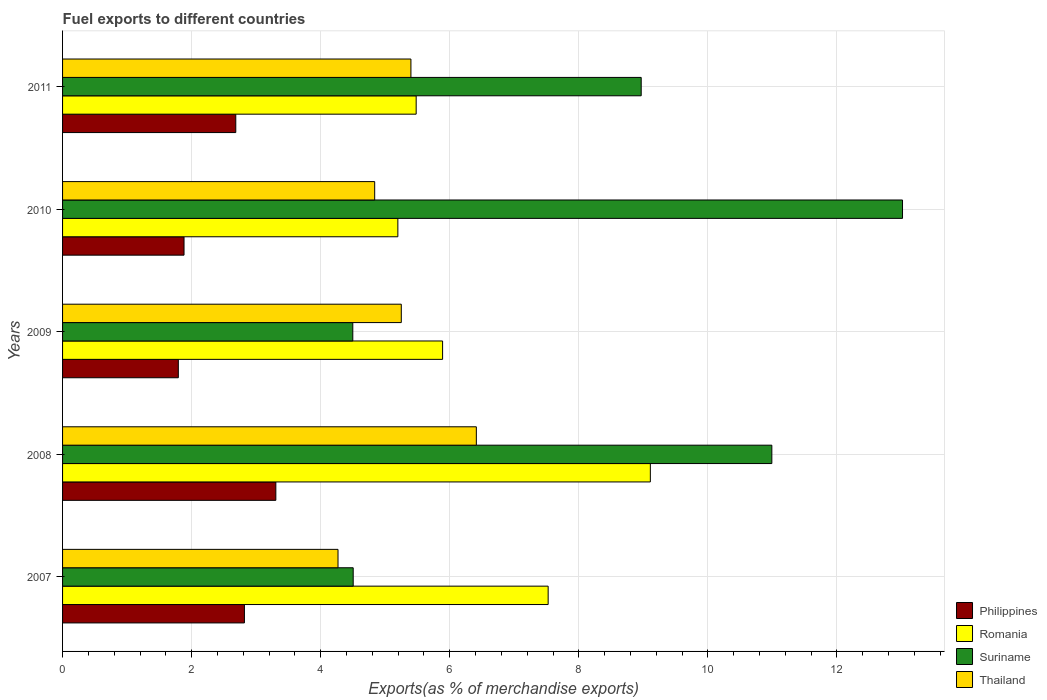How many different coloured bars are there?
Provide a succinct answer. 4. Are the number of bars per tick equal to the number of legend labels?
Keep it short and to the point. Yes. How many bars are there on the 1st tick from the bottom?
Provide a succinct answer. 4. In how many cases, is the number of bars for a given year not equal to the number of legend labels?
Give a very brief answer. 0. What is the percentage of exports to different countries in Romania in 2009?
Keep it short and to the point. 5.89. Across all years, what is the maximum percentage of exports to different countries in Thailand?
Your answer should be very brief. 6.41. Across all years, what is the minimum percentage of exports to different countries in Romania?
Your answer should be compact. 5.2. In which year was the percentage of exports to different countries in Philippines minimum?
Offer a very short reply. 2009. What is the total percentage of exports to different countries in Romania in the graph?
Make the answer very short. 33.2. What is the difference between the percentage of exports to different countries in Thailand in 2009 and that in 2011?
Make the answer very short. -0.15. What is the difference between the percentage of exports to different countries in Suriname in 2010 and the percentage of exports to different countries in Romania in 2011?
Offer a terse response. 7.54. What is the average percentage of exports to different countries in Philippines per year?
Your answer should be compact. 2.5. In the year 2009, what is the difference between the percentage of exports to different countries in Suriname and percentage of exports to different countries in Thailand?
Provide a succinct answer. -0.75. In how many years, is the percentage of exports to different countries in Romania greater than 12.4 %?
Offer a very short reply. 0. What is the ratio of the percentage of exports to different countries in Romania in 2008 to that in 2011?
Your response must be concise. 1.66. Is the percentage of exports to different countries in Philippines in 2008 less than that in 2010?
Keep it short and to the point. No. What is the difference between the highest and the second highest percentage of exports to different countries in Philippines?
Offer a terse response. 0.49. What is the difference between the highest and the lowest percentage of exports to different countries in Romania?
Offer a very short reply. 3.91. In how many years, is the percentage of exports to different countries in Romania greater than the average percentage of exports to different countries in Romania taken over all years?
Ensure brevity in your answer.  2. Is it the case that in every year, the sum of the percentage of exports to different countries in Suriname and percentage of exports to different countries in Romania is greater than the sum of percentage of exports to different countries in Thailand and percentage of exports to different countries in Philippines?
Keep it short and to the point. No. What does the 4th bar from the top in 2007 represents?
Your response must be concise. Philippines. What does the 1st bar from the bottom in 2011 represents?
Your response must be concise. Philippines. Is it the case that in every year, the sum of the percentage of exports to different countries in Philippines and percentage of exports to different countries in Romania is greater than the percentage of exports to different countries in Suriname?
Your response must be concise. No. What is the difference between two consecutive major ticks on the X-axis?
Make the answer very short. 2. Are the values on the major ticks of X-axis written in scientific E-notation?
Provide a short and direct response. No. Where does the legend appear in the graph?
Your answer should be compact. Bottom right. How many legend labels are there?
Offer a terse response. 4. What is the title of the graph?
Your answer should be compact. Fuel exports to different countries. Does "Monaco" appear as one of the legend labels in the graph?
Provide a short and direct response. No. What is the label or title of the X-axis?
Your answer should be very brief. Exports(as % of merchandise exports). What is the label or title of the Y-axis?
Ensure brevity in your answer.  Years. What is the Exports(as % of merchandise exports) in Philippines in 2007?
Give a very brief answer. 2.82. What is the Exports(as % of merchandise exports) of Romania in 2007?
Keep it short and to the point. 7.52. What is the Exports(as % of merchandise exports) in Suriname in 2007?
Keep it short and to the point. 4.5. What is the Exports(as % of merchandise exports) of Thailand in 2007?
Keep it short and to the point. 4.27. What is the Exports(as % of merchandise exports) in Philippines in 2008?
Offer a very short reply. 3.3. What is the Exports(as % of merchandise exports) of Romania in 2008?
Your response must be concise. 9.11. What is the Exports(as % of merchandise exports) of Suriname in 2008?
Provide a short and direct response. 10.99. What is the Exports(as % of merchandise exports) in Thailand in 2008?
Make the answer very short. 6.41. What is the Exports(as % of merchandise exports) of Philippines in 2009?
Your answer should be compact. 1.79. What is the Exports(as % of merchandise exports) of Romania in 2009?
Ensure brevity in your answer.  5.89. What is the Exports(as % of merchandise exports) of Suriname in 2009?
Your answer should be compact. 4.5. What is the Exports(as % of merchandise exports) of Thailand in 2009?
Offer a terse response. 5.25. What is the Exports(as % of merchandise exports) in Philippines in 2010?
Offer a terse response. 1.88. What is the Exports(as % of merchandise exports) of Romania in 2010?
Offer a terse response. 5.2. What is the Exports(as % of merchandise exports) of Suriname in 2010?
Make the answer very short. 13.02. What is the Exports(as % of merchandise exports) of Thailand in 2010?
Keep it short and to the point. 4.84. What is the Exports(as % of merchandise exports) in Philippines in 2011?
Provide a succinct answer. 2.68. What is the Exports(as % of merchandise exports) of Romania in 2011?
Your answer should be compact. 5.48. What is the Exports(as % of merchandise exports) of Suriname in 2011?
Keep it short and to the point. 8.97. What is the Exports(as % of merchandise exports) of Thailand in 2011?
Ensure brevity in your answer.  5.4. Across all years, what is the maximum Exports(as % of merchandise exports) in Philippines?
Provide a succinct answer. 3.3. Across all years, what is the maximum Exports(as % of merchandise exports) of Romania?
Ensure brevity in your answer.  9.11. Across all years, what is the maximum Exports(as % of merchandise exports) of Suriname?
Keep it short and to the point. 13.02. Across all years, what is the maximum Exports(as % of merchandise exports) in Thailand?
Keep it short and to the point. 6.41. Across all years, what is the minimum Exports(as % of merchandise exports) in Philippines?
Keep it short and to the point. 1.79. Across all years, what is the minimum Exports(as % of merchandise exports) in Romania?
Make the answer very short. 5.2. Across all years, what is the minimum Exports(as % of merchandise exports) in Suriname?
Offer a very short reply. 4.5. Across all years, what is the minimum Exports(as % of merchandise exports) in Thailand?
Offer a very short reply. 4.27. What is the total Exports(as % of merchandise exports) of Philippines in the graph?
Give a very brief answer. 12.48. What is the total Exports(as % of merchandise exports) of Romania in the graph?
Make the answer very short. 33.2. What is the total Exports(as % of merchandise exports) of Suriname in the graph?
Ensure brevity in your answer.  41.97. What is the total Exports(as % of merchandise exports) of Thailand in the graph?
Ensure brevity in your answer.  26.16. What is the difference between the Exports(as % of merchandise exports) in Philippines in 2007 and that in 2008?
Provide a short and direct response. -0.49. What is the difference between the Exports(as % of merchandise exports) in Romania in 2007 and that in 2008?
Your response must be concise. -1.58. What is the difference between the Exports(as % of merchandise exports) in Suriname in 2007 and that in 2008?
Keep it short and to the point. -6.49. What is the difference between the Exports(as % of merchandise exports) of Thailand in 2007 and that in 2008?
Offer a very short reply. -2.14. What is the difference between the Exports(as % of merchandise exports) of Philippines in 2007 and that in 2009?
Keep it short and to the point. 1.02. What is the difference between the Exports(as % of merchandise exports) of Romania in 2007 and that in 2009?
Ensure brevity in your answer.  1.64. What is the difference between the Exports(as % of merchandise exports) of Suriname in 2007 and that in 2009?
Offer a very short reply. 0.01. What is the difference between the Exports(as % of merchandise exports) in Thailand in 2007 and that in 2009?
Give a very brief answer. -0.98. What is the difference between the Exports(as % of merchandise exports) in Philippines in 2007 and that in 2010?
Give a very brief answer. 0.94. What is the difference between the Exports(as % of merchandise exports) in Romania in 2007 and that in 2010?
Make the answer very short. 2.33. What is the difference between the Exports(as % of merchandise exports) of Suriname in 2007 and that in 2010?
Ensure brevity in your answer.  -8.51. What is the difference between the Exports(as % of merchandise exports) of Thailand in 2007 and that in 2010?
Ensure brevity in your answer.  -0.57. What is the difference between the Exports(as % of merchandise exports) of Philippines in 2007 and that in 2011?
Give a very brief answer. 0.13. What is the difference between the Exports(as % of merchandise exports) of Romania in 2007 and that in 2011?
Offer a very short reply. 2.05. What is the difference between the Exports(as % of merchandise exports) in Suriname in 2007 and that in 2011?
Make the answer very short. -4.46. What is the difference between the Exports(as % of merchandise exports) in Thailand in 2007 and that in 2011?
Your answer should be compact. -1.13. What is the difference between the Exports(as % of merchandise exports) of Philippines in 2008 and that in 2009?
Keep it short and to the point. 1.51. What is the difference between the Exports(as % of merchandise exports) in Romania in 2008 and that in 2009?
Ensure brevity in your answer.  3.22. What is the difference between the Exports(as % of merchandise exports) of Suriname in 2008 and that in 2009?
Offer a very short reply. 6.49. What is the difference between the Exports(as % of merchandise exports) of Thailand in 2008 and that in 2009?
Your answer should be compact. 1.16. What is the difference between the Exports(as % of merchandise exports) of Philippines in 2008 and that in 2010?
Offer a terse response. 1.42. What is the difference between the Exports(as % of merchandise exports) of Romania in 2008 and that in 2010?
Make the answer very short. 3.91. What is the difference between the Exports(as % of merchandise exports) in Suriname in 2008 and that in 2010?
Keep it short and to the point. -2.02. What is the difference between the Exports(as % of merchandise exports) of Thailand in 2008 and that in 2010?
Provide a succinct answer. 1.58. What is the difference between the Exports(as % of merchandise exports) in Philippines in 2008 and that in 2011?
Offer a terse response. 0.62. What is the difference between the Exports(as % of merchandise exports) in Romania in 2008 and that in 2011?
Give a very brief answer. 3.63. What is the difference between the Exports(as % of merchandise exports) in Suriname in 2008 and that in 2011?
Offer a very short reply. 2.02. What is the difference between the Exports(as % of merchandise exports) in Thailand in 2008 and that in 2011?
Provide a succinct answer. 1.01. What is the difference between the Exports(as % of merchandise exports) of Philippines in 2009 and that in 2010?
Give a very brief answer. -0.09. What is the difference between the Exports(as % of merchandise exports) in Romania in 2009 and that in 2010?
Your answer should be very brief. 0.69. What is the difference between the Exports(as % of merchandise exports) in Suriname in 2009 and that in 2010?
Keep it short and to the point. -8.52. What is the difference between the Exports(as % of merchandise exports) of Thailand in 2009 and that in 2010?
Your answer should be compact. 0.41. What is the difference between the Exports(as % of merchandise exports) in Philippines in 2009 and that in 2011?
Offer a terse response. -0.89. What is the difference between the Exports(as % of merchandise exports) of Romania in 2009 and that in 2011?
Offer a terse response. 0.41. What is the difference between the Exports(as % of merchandise exports) in Suriname in 2009 and that in 2011?
Ensure brevity in your answer.  -4.47. What is the difference between the Exports(as % of merchandise exports) of Thailand in 2009 and that in 2011?
Your answer should be very brief. -0.15. What is the difference between the Exports(as % of merchandise exports) in Philippines in 2010 and that in 2011?
Offer a terse response. -0.8. What is the difference between the Exports(as % of merchandise exports) in Romania in 2010 and that in 2011?
Provide a succinct answer. -0.28. What is the difference between the Exports(as % of merchandise exports) of Suriname in 2010 and that in 2011?
Keep it short and to the point. 4.05. What is the difference between the Exports(as % of merchandise exports) of Thailand in 2010 and that in 2011?
Your answer should be compact. -0.56. What is the difference between the Exports(as % of merchandise exports) of Philippines in 2007 and the Exports(as % of merchandise exports) of Romania in 2008?
Keep it short and to the point. -6.29. What is the difference between the Exports(as % of merchandise exports) in Philippines in 2007 and the Exports(as % of merchandise exports) in Suriname in 2008?
Offer a terse response. -8.17. What is the difference between the Exports(as % of merchandise exports) in Philippines in 2007 and the Exports(as % of merchandise exports) in Thailand in 2008?
Your answer should be very brief. -3.59. What is the difference between the Exports(as % of merchandise exports) of Romania in 2007 and the Exports(as % of merchandise exports) of Suriname in 2008?
Your answer should be very brief. -3.47. What is the difference between the Exports(as % of merchandise exports) in Romania in 2007 and the Exports(as % of merchandise exports) in Thailand in 2008?
Your answer should be compact. 1.11. What is the difference between the Exports(as % of merchandise exports) in Suriname in 2007 and the Exports(as % of merchandise exports) in Thailand in 2008?
Give a very brief answer. -1.91. What is the difference between the Exports(as % of merchandise exports) of Philippines in 2007 and the Exports(as % of merchandise exports) of Romania in 2009?
Offer a very short reply. -3.07. What is the difference between the Exports(as % of merchandise exports) in Philippines in 2007 and the Exports(as % of merchandise exports) in Suriname in 2009?
Ensure brevity in your answer.  -1.68. What is the difference between the Exports(as % of merchandise exports) of Philippines in 2007 and the Exports(as % of merchandise exports) of Thailand in 2009?
Make the answer very short. -2.43. What is the difference between the Exports(as % of merchandise exports) in Romania in 2007 and the Exports(as % of merchandise exports) in Suriname in 2009?
Keep it short and to the point. 3.03. What is the difference between the Exports(as % of merchandise exports) in Romania in 2007 and the Exports(as % of merchandise exports) in Thailand in 2009?
Provide a short and direct response. 2.28. What is the difference between the Exports(as % of merchandise exports) of Suriname in 2007 and the Exports(as % of merchandise exports) of Thailand in 2009?
Offer a very short reply. -0.75. What is the difference between the Exports(as % of merchandise exports) of Philippines in 2007 and the Exports(as % of merchandise exports) of Romania in 2010?
Your response must be concise. -2.38. What is the difference between the Exports(as % of merchandise exports) in Philippines in 2007 and the Exports(as % of merchandise exports) in Suriname in 2010?
Ensure brevity in your answer.  -10.2. What is the difference between the Exports(as % of merchandise exports) in Philippines in 2007 and the Exports(as % of merchandise exports) in Thailand in 2010?
Offer a very short reply. -2.02. What is the difference between the Exports(as % of merchandise exports) in Romania in 2007 and the Exports(as % of merchandise exports) in Suriname in 2010?
Ensure brevity in your answer.  -5.49. What is the difference between the Exports(as % of merchandise exports) in Romania in 2007 and the Exports(as % of merchandise exports) in Thailand in 2010?
Provide a succinct answer. 2.69. What is the difference between the Exports(as % of merchandise exports) in Suriname in 2007 and the Exports(as % of merchandise exports) in Thailand in 2010?
Your answer should be very brief. -0.33. What is the difference between the Exports(as % of merchandise exports) of Philippines in 2007 and the Exports(as % of merchandise exports) of Romania in 2011?
Provide a short and direct response. -2.66. What is the difference between the Exports(as % of merchandise exports) in Philippines in 2007 and the Exports(as % of merchandise exports) in Suriname in 2011?
Your answer should be compact. -6.15. What is the difference between the Exports(as % of merchandise exports) in Philippines in 2007 and the Exports(as % of merchandise exports) in Thailand in 2011?
Make the answer very short. -2.58. What is the difference between the Exports(as % of merchandise exports) of Romania in 2007 and the Exports(as % of merchandise exports) of Suriname in 2011?
Your answer should be very brief. -1.44. What is the difference between the Exports(as % of merchandise exports) of Romania in 2007 and the Exports(as % of merchandise exports) of Thailand in 2011?
Offer a very short reply. 2.13. What is the difference between the Exports(as % of merchandise exports) of Suriname in 2007 and the Exports(as % of merchandise exports) of Thailand in 2011?
Your response must be concise. -0.89. What is the difference between the Exports(as % of merchandise exports) of Philippines in 2008 and the Exports(as % of merchandise exports) of Romania in 2009?
Your answer should be very brief. -2.58. What is the difference between the Exports(as % of merchandise exports) in Philippines in 2008 and the Exports(as % of merchandise exports) in Suriname in 2009?
Your answer should be very brief. -1.19. What is the difference between the Exports(as % of merchandise exports) in Philippines in 2008 and the Exports(as % of merchandise exports) in Thailand in 2009?
Your response must be concise. -1.94. What is the difference between the Exports(as % of merchandise exports) of Romania in 2008 and the Exports(as % of merchandise exports) of Suriname in 2009?
Provide a short and direct response. 4.61. What is the difference between the Exports(as % of merchandise exports) of Romania in 2008 and the Exports(as % of merchandise exports) of Thailand in 2009?
Your response must be concise. 3.86. What is the difference between the Exports(as % of merchandise exports) in Suriname in 2008 and the Exports(as % of merchandise exports) in Thailand in 2009?
Offer a terse response. 5.74. What is the difference between the Exports(as % of merchandise exports) in Philippines in 2008 and the Exports(as % of merchandise exports) in Romania in 2010?
Keep it short and to the point. -1.89. What is the difference between the Exports(as % of merchandise exports) in Philippines in 2008 and the Exports(as % of merchandise exports) in Suriname in 2010?
Give a very brief answer. -9.71. What is the difference between the Exports(as % of merchandise exports) of Philippines in 2008 and the Exports(as % of merchandise exports) of Thailand in 2010?
Ensure brevity in your answer.  -1.53. What is the difference between the Exports(as % of merchandise exports) of Romania in 2008 and the Exports(as % of merchandise exports) of Suriname in 2010?
Your answer should be compact. -3.91. What is the difference between the Exports(as % of merchandise exports) in Romania in 2008 and the Exports(as % of merchandise exports) in Thailand in 2010?
Offer a very short reply. 4.27. What is the difference between the Exports(as % of merchandise exports) of Suriname in 2008 and the Exports(as % of merchandise exports) of Thailand in 2010?
Your response must be concise. 6.15. What is the difference between the Exports(as % of merchandise exports) of Philippines in 2008 and the Exports(as % of merchandise exports) of Romania in 2011?
Offer a very short reply. -2.17. What is the difference between the Exports(as % of merchandise exports) in Philippines in 2008 and the Exports(as % of merchandise exports) in Suriname in 2011?
Make the answer very short. -5.66. What is the difference between the Exports(as % of merchandise exports) in Philippines in 2008 and the Exports(as % of merchandise exports) in Thailand in 2011?
Provide a short and direct response. -2.09. What is the difference between the Exports(as % of merchandise exports) in Romania in 2008 and the Exports(as % of merchandise exports) in Suriname in 2011?
Make the answer very short. 0.14. What is the difference between the Exports(as % of merchandise exports) in Romania in 2008 and the Exports(as % of merchandise exports) in Thailand in 2011?
Offer a terse response. 3.71. What is the difference between the Exports(as % of merchandise exports) of Suriname in 2008 and the Exports(as % of merchandise exports) of Thailand in 2011?
Ensure brevity in your answer.  5.59. What is the difference between the Exports(as % of merchandise exports) of Philippines in 2009 and the Exports(as % of merchandise exports) of Romania in 2010?
Provide a succinct answer. -3.4. What is the difference between the Exports(as % of merchandise exports) in Philippines in 2009 and the Exports(as % of merchandise exports) in Suriname in 2010?
Ensure brevity in your answer.  -11.22. What is the difference between the Exports(as % of merchandise exports) in Philippines in 2009 and the Exports(as % of merchandise exports) in Thailand in 2010?
Keep it short and to the point. -3.04. What is the difference between the Exports(as % of merchandise exports) in Romania in 2009 and the Exports(as % of merchandise exports) in Suriname in 2010?
Your answer should be very brief. -7.13. What is the difference between the Exports(as % of merchandise exports) of Romania in 2009 and the Exports(as % of merchandise exports) of Thailand in 2010?
Provide a short and direct response. 1.05. What is the difference between the Exports(as % of merchandise exports) of Suriname in 2009 and the Exports(as % of merchandise exports) of Thailand in 2010?
Your answer should be compact. -0.34. What is the difference between the Exports(as % of merchandise exports) in Philippines in 2009 and the Exports(as % of merchandise exports) in Romania in 2011?
Ensure brevity in your answer.  -3.69. What is the difference between the Exports(as % of merchandise exports) of Philippines in 2009 and the Exports(as % of merchandise exports) of Suriname in 2011?
Ensure brevity in your answer.  -7.17. What is the difference between the Exports(as % of merchandise exports) in Philippines in 2009 and the Exports(as % of merchandise exports) in Thailand in 2011?
Your answer should be compact. -3.6. What is the difference between the Exports(as % of merchandise exports) of Romania in 2009 and the Exports(as % of merchandise exports) of Suriname in 2011?
Your answer should be very brief. -3.08. What is the difference between the Exports(as % of merchandise exports) of Romania in 2009 and the Exports(as % of merchandise exports) of Thailand in 2011?
Your response must be concise. 0.49. What is the difference between the Exports(as % of merchandise exports) in Suriname in 2009 and the Exports(as % of merchandise exports) in Thailand in 2011?
Offer a very short reply. -0.9. What is the difference between the Exports(as % of merchandise exports) of Philippines in 2010 and the Exports(as % of merchandise exports) of Romania in 2011?
Keep it short and to the point. -3.6. What is the difference between the Exports(as % of merchandise exports) in Philippines in 2010 and the Exports(as % of merchandise exports) in Suriname in 2011?
Make the answer very short. -7.08. What is the difference between the Exports(as % of merchandise exports) of Philippines in 2010 and the Exports(as % of merchandise exports) of Thailand in 2011?
Provide a succinct answer. -3.52. What is the difference between the Exports(as % of merchandise exports) in Romania in 2010 and the Exports(as % of merchandise exports) in Suriname in 2011?
Your answer should be very brief. -3.77. What is the difference between the Exports(as % of merchandise exports) in Romania in 2010 and the Exports(as % of merchandise exports) in Thailand in 2011?
Offer a very short reply. -0.2. What is the difference between the Exports(as % of merchandise exports) of Suriname in 2010 and the Exports(as % of merchandise exports) of Thailand in 2011?
Provide a succinct answer. 7.62. What is the average Exports(as % of merchandise exports) in Philippines per year?
Ensure brevity in your answer.  2.5. What is the average Exports(as % of merchandise exports) in Romania per year?
Ensure brevity in your answer.  6.64. What is the average Exports(as % of merchandise exports) of Suriname per year?
Offer a terse response. 8.39. What is the average Exports(as % of merchandise exports) in Thailand per year?
Offer a very short reply. 5.23. In the year 2007, what is the difference between the Exports(as % of merchandise exports) of Philippines and Exports(as % of merchandise exports) of Romania?
Provide a succinct answer. -4.71. In the year 2007, what is the difference between the Exports(as % of merchandise exports) of Philippines and Exports(as % of merchandise exports) of Suriname?
Make the answer very short. -1.69. In the year 2007, what is the difference between the Exports(as % of merchandise exports) of Philippines and Exports(as % of merchandise exports) of Thailand?
Make the answer very short. -1.45. In the year 2007, what is the difference between the Exports(as % of merchandise exports) in Romania and Exports(as % of merchandise exports) in Suriname?
Give a very brief answer. 3.02. In the year 2007, what is the difference between the Exports(as % of merchandise exports) of Romania and Exports(as % of merchandise exports) of Thailand?
Your response must be concise. 3.26. In the year 2007, what is the difference between the Exports(as % of merchandise exports) of Suriname and Exports(as % of merchandise exports) of Thailand?
Provide a short and direct response. 0.24. In the year 2008, what is the difference between the Exports(as % of merchandise exports) in Philippines and Exports(as % of merchandise exports) in Romania?
Provide a succinct answer. -5.8. In the year 2008, what is the difference between the Exports(as % of merchandise exports) in Philippines and Exports(as % of merchandise exports) in Suriname?
Provide a short and direct response. -7.69. In the year 2008, what is the difference between the Exports(as % of merchandise exports) of Philippines and Exports(as % of merchandise exports) of Thailand?
Provide a succinct answer. -3.11. In the year 2008, what is the difference between the Exports(as % of merchandise exports) in Romania and Exports(as % of merchandise exports) in Suriname?
Your answer should be very brief. -1.88. In the year 2008, what is the difference between the Exports(as % of merchandise exports) of Romania and Exports(as % of merchandise exports) of Thailand?
Offer a very short reply. 2.7. In the year 2008, what is the difference between the Exports(as % of merchandise exports) in Suriname and Exports(as % of merchandise exports) in Thailand?
Your response must be concise. 4.58. In the year 2009, what is the difference between the Exports(as % of merchandise exports) in Philippines and Exports(as % of merchandise exports) in Romania?
Give a very brief answer. -4.1. In the year 2009, what is the difference between the Exports(as % of merchandise exports) in Philippines and Exports(as % of merchandise exports) in Suriname?
Your answer should be compact. -2.7. In the year 2009, what is the difference between the Exports(as % of merchandise exports) in Philippines and Exports(as % of merchandise exports) in Thailand?
Offer a very short reply. -3.46. In the year 2009, what is the difference between the Exports(as % of merchandise exports) of Romania and Exports(as % of merchandise exports) of Suriname?
Offer a very short reply. 1.39. In the year 2009, what is the difference between the Exports(as % of merchandise exports) in Romania and Exports(as % of merchandise exports) in Thailand?
Ensure brevity in your answer.  0.64. In the year 2009, what is the difference between the Exports(as % of merchandise exports) of Suriname and Exports(as % of merchandise exports) of Thailand?
Make the answer very short. -0.75. In the year 2010, what is the difference between the Exports(as % of merchandise exports) in Philippines and Exports(as % of merchandise exports) in Romania?
Your response must be concise. -3.31. In the year 2010, what is the difference between the Exports(as % of merchandise exports) in Philippines and Exports(as % of merchandise exports) in Suriname?
Your response must be concise. -11.13. In the year 2010, what is the difference between the Exports(as % of merchandise exports) of Philippines and Exports(as % of merchandise exports) of Thailand?
Provide a succinct answer. -2.95. In the year 2010, what is the difference between the Exports(as % of merchandise exports) of Romania and Exports(as % of merchandise exports) of Suriname?
Give a very brief answer. -7.82. In the year 2010, what is the difference between the Exports(as % of merchandise exports) in Romania and Exports(as % of merchandise exports) in Thailand?
Offer a terse response. 0.36. In the year 2010, what is the difference between the Exports(as % of merchandise exports) in Suriname and Exports(as % of merchandise exports) in Thailand?
Offer a very short reply. 8.18. In the year 2011, what is the difference between the Exports(as % of merchandise exports) in Philippines and Exports(as % of merchandise exports) in Romania?
Your answer should be very brief. -2.8. In the year 2011, what is the difference between the Exports(as % of merchandise exports) in Philippines and Exports(as % of merchandise exports) in Suriname?
Provide a succinct answer. -6.28. In the year 2011, what is the difference between the Exports(as % of merchandise exports) of Philippines and Exports(as % of merchandise exports) of Thailand?
Your answer should be very brief. -2.71. In the year 2011, what is the difference between the Exports(as % of merchandise exports) in Romania and Exports(as % of merchandise exports) in Suriname?
Provide a succinct answer. -3.49. In the year 2011, what is the difference between the Exports(as % of merchandise exports) in Romania and Exports(as % of merchandise exports) in Thailand?
Make the answer very short. 0.08. In the year 2011, what is the difference between the Exports(as % of merchandise exports) of Suriname and Exports(as % of merchandise exports) of Thailand?
Keep it short and to the point. 3.57. What is the ratio of the Exports(as % of merchandise exports) in Philippines in 2007 to that in 2008?
Keep it short and to the point. 0.85. What is the ratio of the Exports(as % of merchandise exports) in Romania in 2007 to that in 2008?
Provide a short and direct response. 0.83. What is the ratio of the Exports(as % of merchandise exports) in Suriname in 2007 to that in 2008?
Your answer should be very brief. 0.41. What is the ratio of the Exports(as % of merchandise exports) in Thailand in 2007 to that in 2008?
Give a very brief answer. 0.67. What is the ratio of the Exports(as % of merchandise exports) in Philippines in 2007 to that in 2009?
Make the answer very short. 1.57. What is the ratio of the Exports(as % of merchandise exports) of Romania in 2007 to that in 2009?
Keep it short and to the point. 1.28. What is the ratio of the Exports(as % of merchandise exports) of Suriname in 2007 to that in 2009?
Provide a succinct answer. 1. What is the ratio of the Exports(as % of merchandise exports) in Thailand in 2007 to that in 2009?
Your answer should be compact. 0.81. What is the ratio of the Exports(as % of merchandise exports) of Philippines in 2007 to that in 2010?
Your answer should be compact. 1.5. What is the ratio of the Exports(as % of merchandise exports) in Romania in 2007 to that in 2010?
Your answer should be very brief. 1.45. What is the ratio of the Exports(as % of merchandise exports) of Suriname in 2007 to that in 2010?
Provide a succinct answer. 0.35. What is the ratio of the Exports(as % of merchandise exports) of Thailand in 2007 to that in 2010?
Keep it short and to the point. 0.88. What is the ratio of the Exports(as % of merchandise exports) of Philippines in 2007 to that in 2011?
Make the answer very short. 1.05. What is the ratio of the Exports(as % of merchandise exports) of Romania in 2007 to that in 2011?
Your response must be concise. 1.37. What is the ratio of the Exports(as % of merchandise exports) of Suriname in 2007 to that in 2011?
Your answer should be very brief. 0.5. What is the ratio of the Exports(as % of merchandise exports) of Thailand in 2007 to that in 2011?
Your response must be concise. 0.79. What is the ratio of the Exports(as % of merchandise exports) in Philippines in 2008 to that in 2009?
Your answer should be very brief. 1.84. What is the ratio of the Exports(as % of merchandise exports) in Romania in 2008 to that in 2009?
Your answer should be compact. 1.55. What is the ratio of the Exports(as % of merchandise exports) of Suriname in 2008 to that in 2009?
Offer a terse response. 2.44. What is the ratio of the Exports(as % of merchandise exports) in Thailand in 2008 to that in 2009?
Your answer should be very brief. 1.22. What is the ratio of the Exports(as % of merchandise exports) in Philippines in 2008 to that in 2010?
Your answer should be very brief. 1.76. What is the ratio of the Exports(as % of merchandise exports) in Romania in 2008 to that in 2010?
Provide a short and direct response. 1.75. What is the ratio of the Exports(as % of merchandise exports) of Suriname in 2008 to that in 2010?
Offer a very short reply. 0.84. What is the ratio of the Exports(as % of merchandise exports) in Thailand in 2008 to that in 2010?
Provide a succinct answer. 1.33. What is the ratio of the Exports(as % of merchandise exports) in Philippines in 2008 to that in 2011?
Provide a succinct answer. 1.23. What is the ratio of the Exports(as % of merchandise exports) in Romania in 2008 to that in 2011?
Your answer should be very brief. 1.66. What is the ratio of the Exports(as % of merchandise exports) of Suriname in 2008 to that in 2011?
Give a very brief answer. 1.23. What is the ratio of the Exports(as % of merchandise exports) of Thailand in 2008 to that in 2011?
Your response must be concise. 1.19. What is the ratio of the Exports(as % of merchandise exports) in Philippines in 2009 to that in 2010?
Offer a very short reply. 0.95. What is the ratio of the Exports(as % of merchandise exports) in Romania in 2009 to that in 2010?
Ensure brevity in your answer.  1.13. What is the ratio of the Exports(as % of merchandise exports) of Suriname in 2009 to that in 2010?
Offer a very short reply. 0.35. What is the ratio of the Exports(as % of merchandise exports) of Thailand in 2009 to that in 2010?
Offer a very short reply. 1.09. What is the ratio of the Exports(as % of merchandise exports) of Philippines in 2009 to that in 2011?
Give a very brief answer. 0.67. What is the ratio of the Exports(as % of merchandise exports) in Romania in 2009 to that in 2011?
Your response must be concise. 1.07. What is the ratio of the Exports(as % of merchandise exports) of Suriname in 2009 to that in 2011?
Offer a terse response. 0.5. What is the ratio of the Exports(as % of merchandise exports) in Thailand in 2009 to that in 2011?
Offer a very short reply. 0.97. What is the ratio of the Exports(as % of merchandise exports) in Philippines in 2010 to that in 2011?
Your response must be concise. 0.7. What is the ratio of the Exports(as % of merchandise exports) in Romania in 2010 to that in 2011?
Your answer should be compact. 0.95. What is the ratio of the Exports(as % of merchandise exports) in Suriname in 2010 to that in 2011?
Provide a succinct answer. 1.45. What is the ratio of the Exports(as % of merchandise exports) of Thailand in 2010 to that in 2011?
Give a very brief answer. 0.9. What is the difference between the highest and the second highest Exports(as % of merchandise exports) of Philippines?
Offer a very short reply. 0.49. What is the difference between the highest and the second highest Exports(as % of merchandise exports) in Romania?
Offer a very short reply. 1.58. What is the difference between the highest and the second highest Exports(as % of merchandise exports) of Suriname?
Provide a succinct answer. 2.02. What is the difference between the highest and the second highest Exports(as % of merchandise exports) of Thailand?
Keep it short and to the point. 1.01. What is the difference between the highest and the lowest Exports(as % of merchandise exports) in Philippines?
Give a very brief answer. 1.51. What is the difference between the highest and the lowest Exports(as % of merchandise exports) of Romania?
Your response must be concise. 3.91. What is the difference between the highest and the lowest Exports(as % of merchandise exports) in Suriname?
Provide a succinct answer. 8.52. What is the difference between the highest and the lowest Exports(as % of merchandise exports) in Thailand?
Your response must be concise. 2.14. 